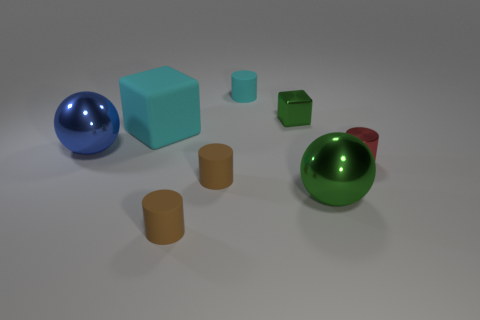Subtract all small rubber cylinders. How many cylinders are left? 1 Add 2 brown matte objects. How many objects exist? 10 Subtract all brown cylinders. How many cylinders are left? 2 Subtract all brown spheres. How many purple blocks are left? 0 Subtract all blocks. How many objects are left? 6 Subtract 1 cylinders. How many cylinders are left? 3 Subtract all cyan rubber cylinders. Subtract all large cyan objects. How many objects are left? 6 Add 2 cyan things. How many cyan things are left? 4 Add 7 tiny metallic cylinders. How many tiny metallic cylinders exist? 8 Subtract 0 green cylinders. How many objects are left? 8 